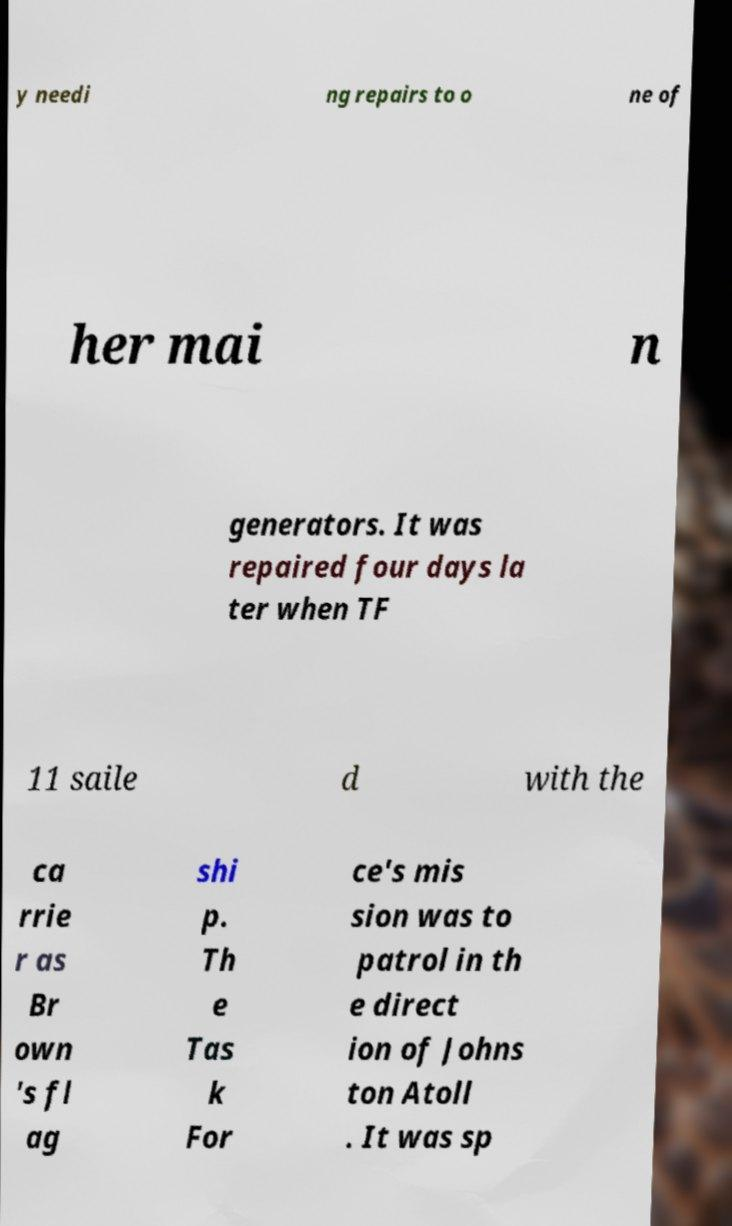Can you accurately transcribe the text from the provided image for me? y needi ng repairs to o ne of her mai n generators. It was repaired four days la ter when TF 11 saile d with the ca rrie r as Br own 's fl ag shi p. Th e Tas k For ce's mis sion was to patrol in th e direct ion of Johns ton Atoll . It was sp 